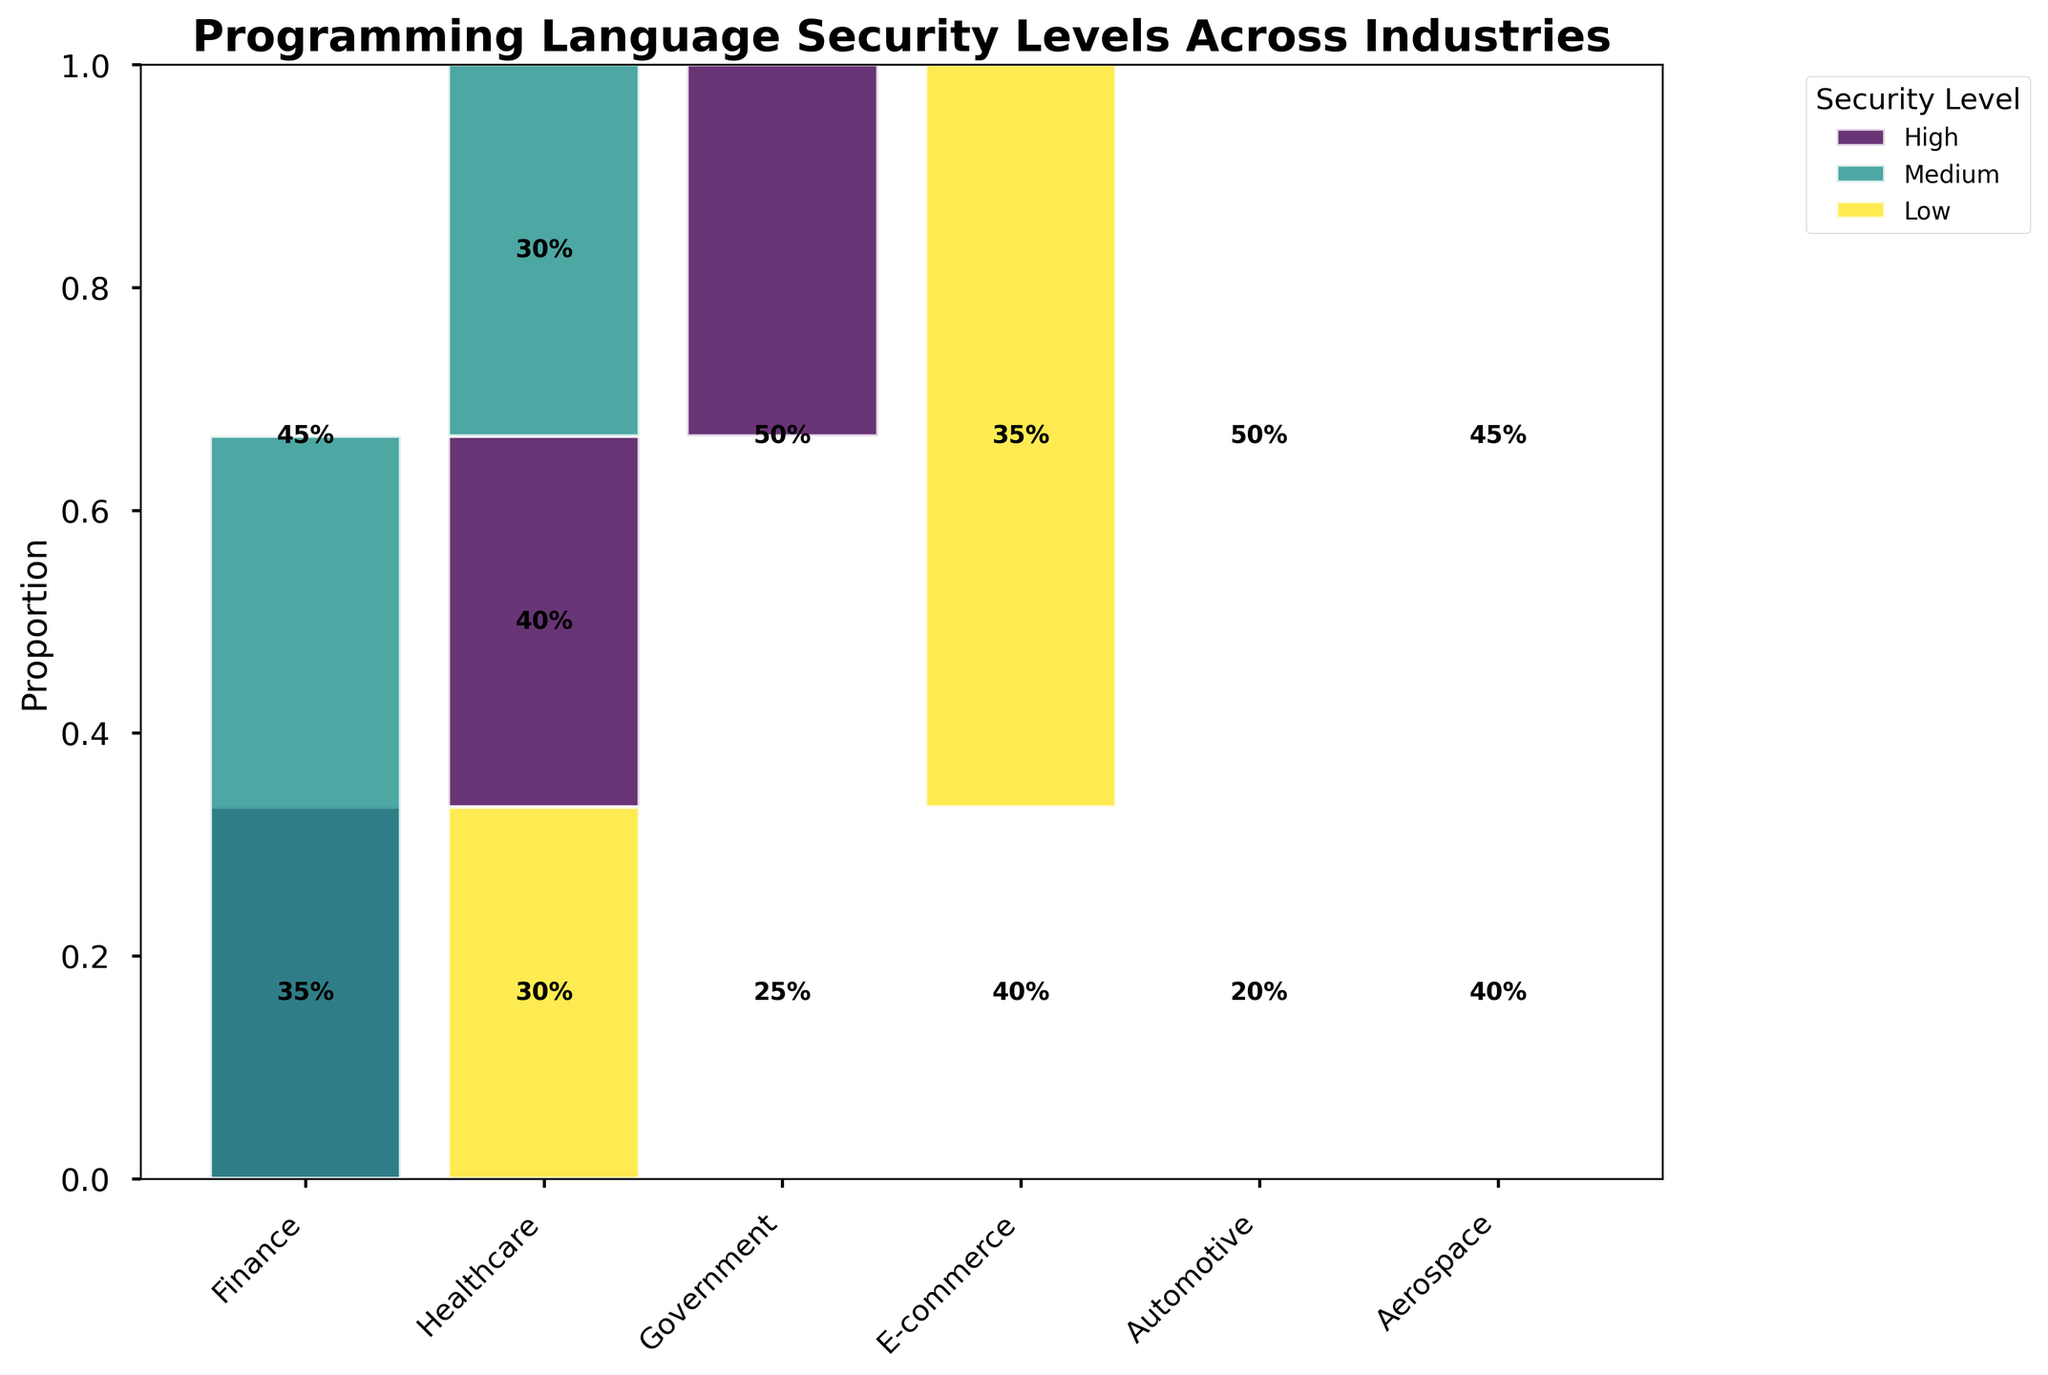What's the title of the plot? The title is typically a textual element displayed prominently at the top of the figure. In this case, it is "Programming Language Security Levels Across Industries".
Answer: Programming Language Security Levels Across Industries Which industry has the highest proportion of high-security programming languages? To find this, examine the segments marked as high security (likely based on a specific color) and identify the tallest segment relative to that industry. The topmost segment in the Finance industry (35%) is the highest among high-security segments.
Answer: Finance What's the combined popularity percentage of medium-security programming languages in the Automotive industry? Sum the popularity percentages for medium-security languages in Automotive. There is only one medium-security segment in Automotive with 50% popularity.
Answer: 50% Compare the proportions of high-security languages between the Government and Aerospace industries. Which has a higher proportion? Identify the segments for high-security languages in both industries and compare their heights. Government's high-security segment is at 25%, while Aerospace's high-security segment is 40%, making Aerospace higher.
Answer: Aerospace How many industries have a low-security programming language proportion of 30% or more? Examine all the industries and identify those with low-security programming languages with proportions of 30% or higher. Only Healthcare meets this criterion.
Answer: 1 Which industry has the lowest representation of medium-security programming languages, and what is that percentage? Find the industry with the shortest bar segment for medium-security programming languages. Aerospace has the smallest segment at 15%.
Answer: Aerospace, 15% What is the total popularity percentage of programming languages in the Finance industry? Sum up the popularity percentages given within the Finance industry: Rust (35%) + Java (45%) + Python (20%) = 100%.
Answer: 100% Which industry has the largest variation in popularity between high and medium-security languages? Calculate the absolute differences between high and medium security segments for each industry. Finance has a difference of 45 - 35 = 10, while Government has 50 - 25 = 25, making Government the largest variation.
Answer: Government If you combine the popularity percentages of high-security languages across all industries, what is the total? Add up the popularity percentages of high-security languages: Finance (35%) + Healthcare (30%) + Government (25%) + Automotive (20%) + Aerospace (40%). The combined total is 150%.
Answer: 150% Which industry has the highest total popularity for low-security languages, and what is that total? Sum up low-security popularity percentages for each industry and find the highest: E-commerce (PHP 35% + Ruby 25% = 60%) is the highest.
Answer: E-commerce, 60% 